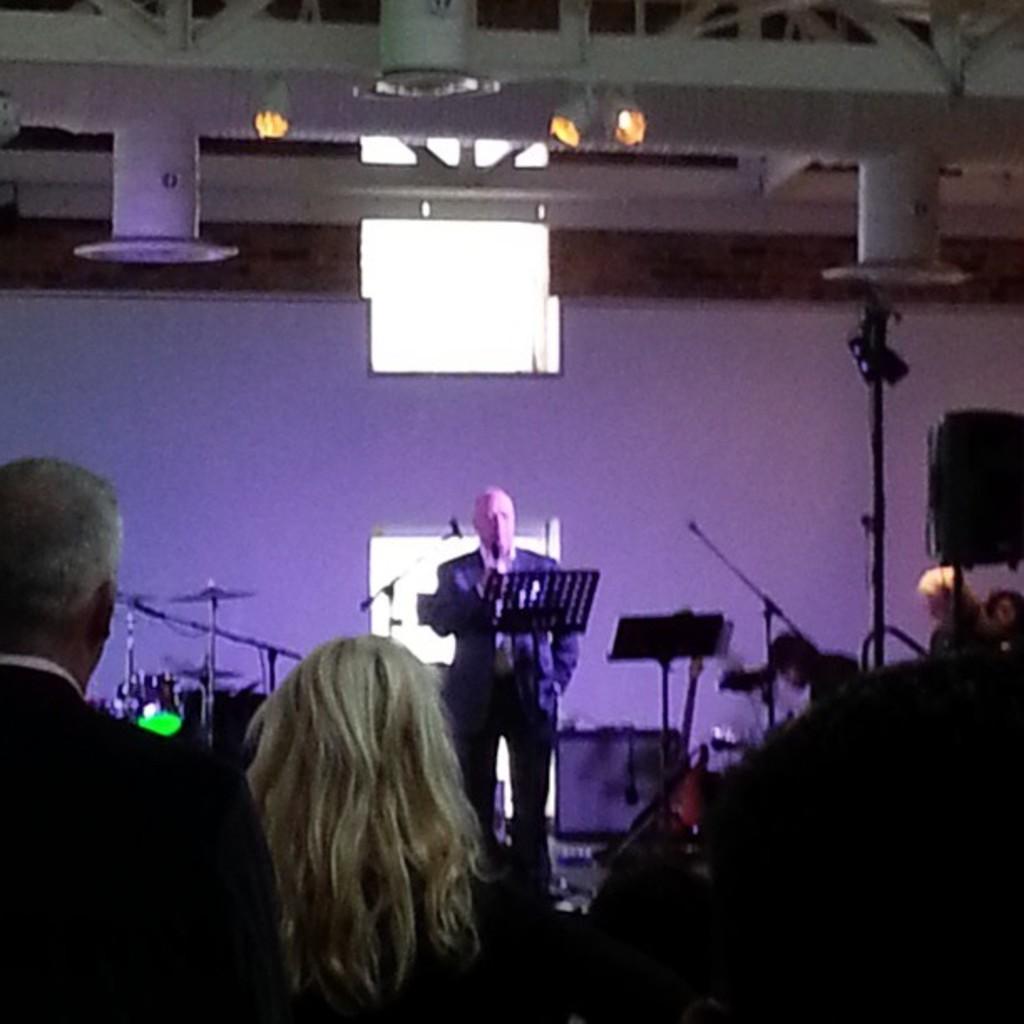How would you summarize this image in a sentence or two? In this image we can see a man standing and smiling in front of a paper stand. Image also consists of people and also musical instruments in the background. At the top there is roof for shelter. We can also see the lights and also wall. 